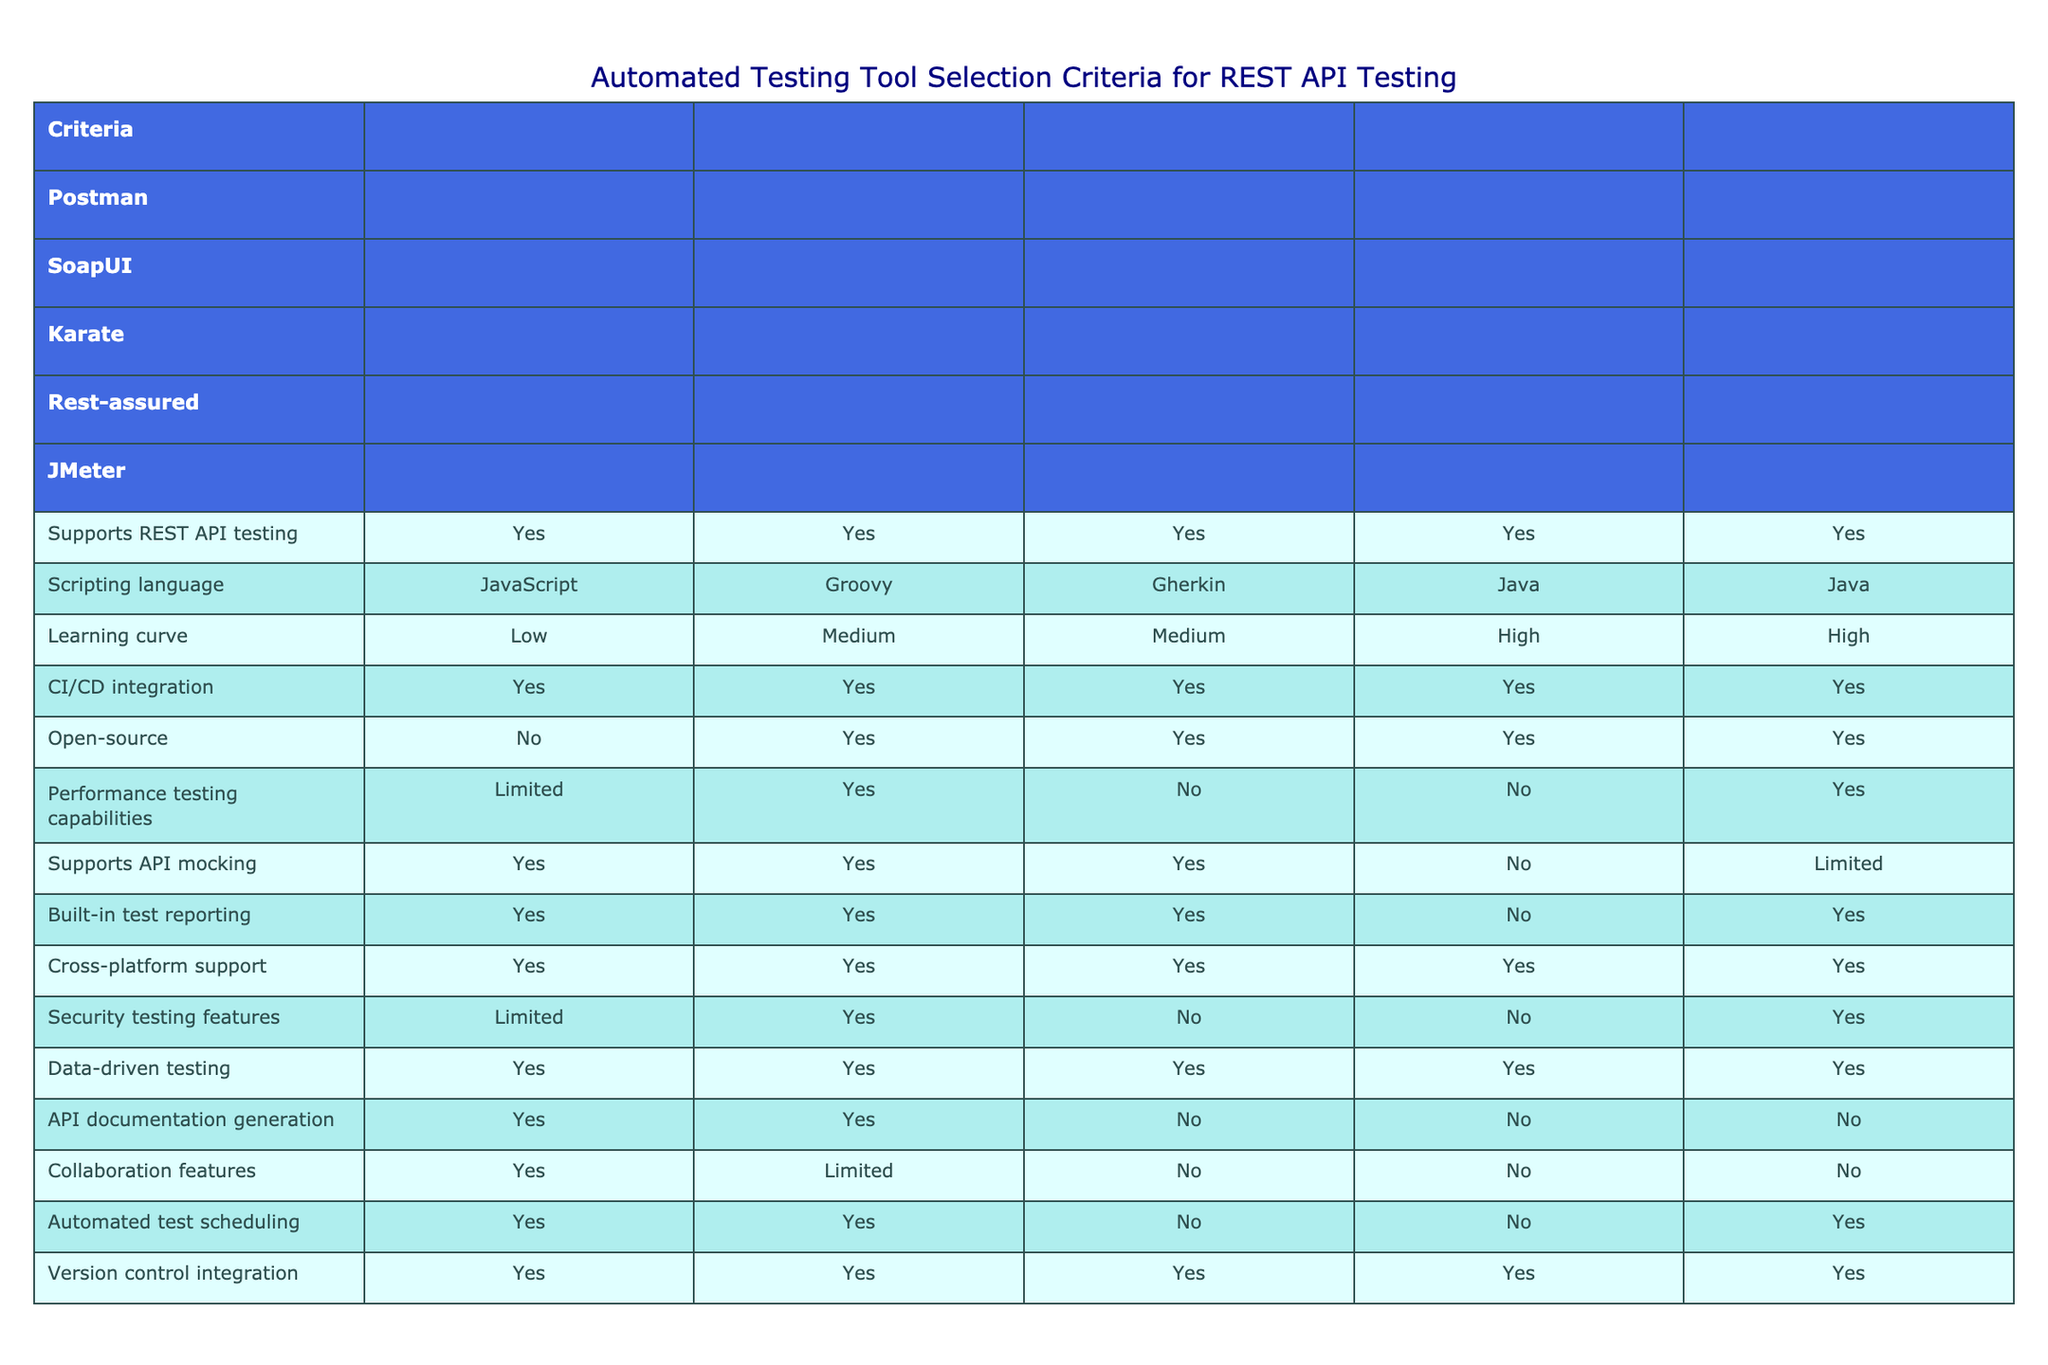What tools support REST API testing? Referring to the table, all listed tools (Postman, SoapUI, Karate, Rest-assured, JMeter) indicate that they support REST API testing, as they all have "Yes" under the corresponding column.
Answer: Postman, SoapUI, Karate, Rest-assured, JMeter Which tools offer open-source versions? Checking the "Open-source" column, SoapUI, Karate, Rest-assured, and JMeter all have "Yes", while Postman has "No". Thus, the four tools with open-source versions are noted.
Answer: SoapUI, Karate, Rest-assured, JMeter How many tools have a low learning curve? From the "Learning curve" column, only Postman has a "Low" learning curve. Comparatively, SoapUI and Karate are medium, while Rest-assured and JMeter have high learning curves.
Answer: 1 What is the only tool that has limited performance testing capabilities? By examining the "Performance testing capabilities" column, it is evident that Postman is the only tool with "Limited" capabilities, while the others have varying levels of performance testing capabilities.
Answer: Postman Which tool has the most features that strictly support collaboration? The "Collaboration features" column shows that Postman has "Yes", while SoapUI has "Limited", and the others do not support collaboration features at all. Hence, Postman offers the most collaboration features among these tools.
Answer: Postman If two tools support API mocking, which ones are they? Looking at the "Supports API mocking" column, both Postman and SoapUI indicate "Yes". Therefore, they are the tools that offer API mocking capabilities.
Answer: Postman, SoapUI Which tool is both open-source and supports data-driven testing, and what is the common scripting language used? Checking both the "Open-source" and "Data-driven testing" columns, we find that SoapUI, Karate, and Rest-assured meet these criteria. The common scripting language for these tools is JavaScript (for SoapUI), Gherkin (for Karate), and Java (for Rest-assured).
Answer: SoapUI, Karate, Rest-assured; JavaScript, Gherkin, Java What is the combined number of tools that provide CI/CD integration and automated test scheduling? By identifying the tools that provide CI/CD integration ("Yes" for all) and those that provide automated test scheduling (Postman, SoapUI, and JMeter), we tally three tools for automated scheduling, resulting in a total of 5 for CI/CD integration and 3 for automated test scheduling. The final count is the same as the CI/CD tools count since all tools fit the integration requirement.
Answer: 5 